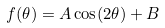Convert formula to latex. <formula><loc_0><loc_0><loc_500><loc_500>f ( \theta ) = A \cos ( 2 \theta ) + B</formula> 